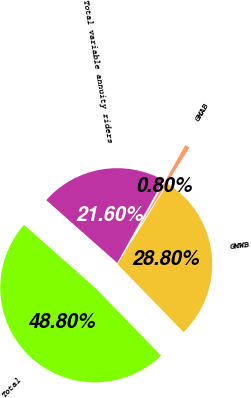Convert chart. <chart><loc_0><loc_0><loc_500><loc_500><pie_chart><fcel>GMWB<fcel>GMAB<fcel>Total variable annuity riders<fcel>Total<nl><fcel>28.8%<fcel>0.8%<fcel>21.6%<fcel>48.8%<nl></chart> 